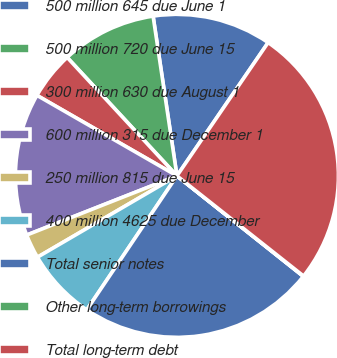Convert chart to OTSL. <chart><loc_0><loc_0><loc_500><loc_500><pie_chart><fcel>500 million 645 due June 1<fcel>500 million 720 due June 15<fcel>300 million 630 due August 1<fcel>600 million 315 due December 1<fcel>250 million 815 due June 15<fcel>400 million 4625 due December<fcel>Total senior notes<fcel>Other long-term borrowings<fcel>Total long-term debt<nl><fcel>11.91%<fcel>9.54%<fcel>4.8%<fcel>14.28%<fcel>2.43%<fcel>7.17%<fcel>23.74%<fcel>0.04%<fcel>26.11%<nl></chart> 